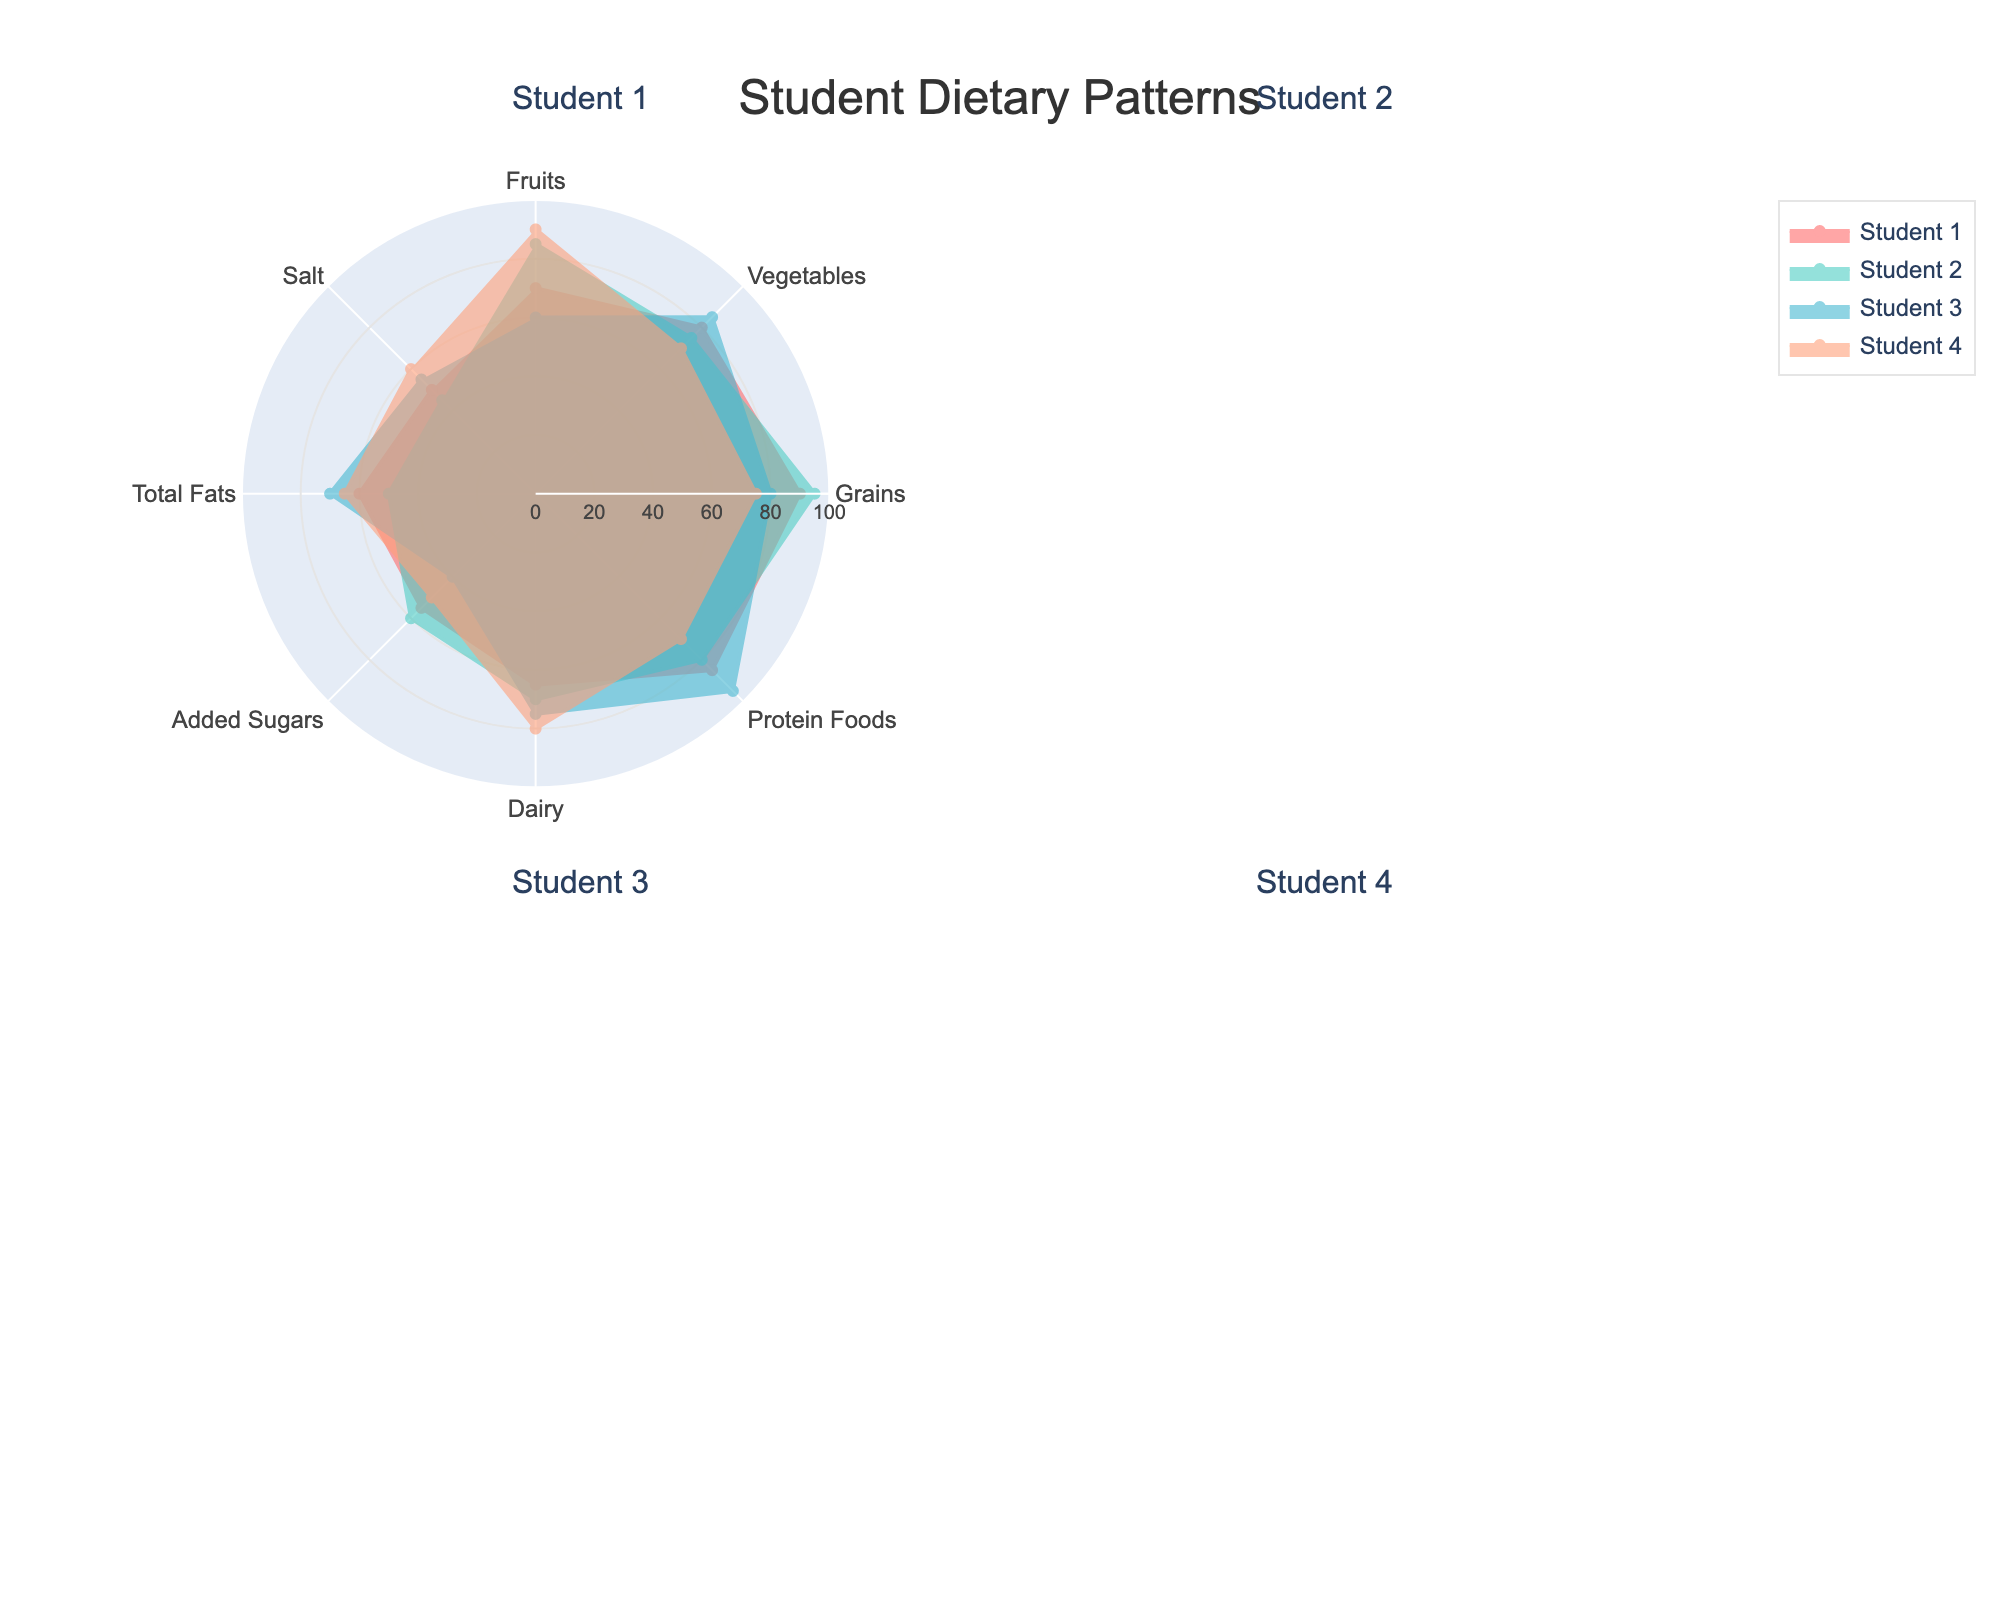How many main food groups and nutrients are shown in the figure? Look at the 'theta' (categories) axis of the polar chart, which lists all the main food groups and nutrients. There are 8 categories shown.
Answer: 8 Which student has the highest intake of protein foods? Compare the values of the "Protein Foods" category across all student subplots. Student 3 has the highest value with 95.
Answer: Student 3 What is the average intake of dairy among all students? Add the dairy intake values of all students and divide by the number of students: (65 + 70 + 75 + 80) / 4 = 72.5.
Answer: 72.5 Which student consumes the least amount of added sugars? Compare the values of the "Added Sugars" category across all student subplots. Student 3 has the lowest value with 40.
Answer: Student 3 How do the fruit intakes of Student 1 and Student 4 compare? Look at the values of the "Fruits" category for both students: Student 1 has 70, and Student 4 has 90. Student 4 consumes more fruits than Student 1.
Answer: Student 4 consumes more In which nutrient category do all students have a value above 70? Review each category's values for all students. The "Grains" category is the only one where every student has a value above 70.
Answer: Grains Which student has the most balanced diet in terms of nutrient intake? A balanced diet would have similar values across all categories. Student 2 has relatively balanced values across different nutrients.
Answer: Student 2 What is the difference in salt intake between Student 1 and Student 2? Compare the salt intake values: Student 1 has 50, and Student 2 has 45. The difference is 50 - 45 = 5.
Answer: 5 Which nutrient shows the greatest variation in intake among students? By visual inspection, the "Added Sugars" category shows a significant variation, with values ranging from 40 to 60.
Answer: Added Sugars What is the combined total fat intake of all students? Add the total fat intake values of all students: 60 + 50 + 70 + 65 = 245.
Answer: 245 